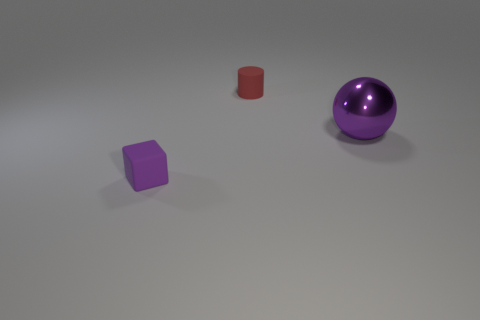Add 3 small red matte things. How many objects exist? 6 Subtract all balls. How many objects are left? 2 Subtract all tiny matte blocks. Subtract all balls. How many objects are left? 1 Add 3 tiny red rubber things. How many tiny red rubber things are left? 4 Add 3 large green matte cubes. How many large green matte cubes exist? 3 Subtract 0 cyan cylinders. How many objects are left? 3 